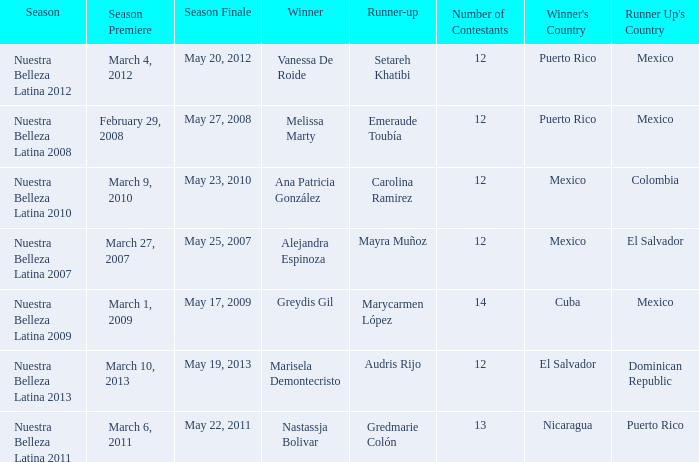What season's premiere had puerto rico winning on May 20, 2012? March 4, 2012. 